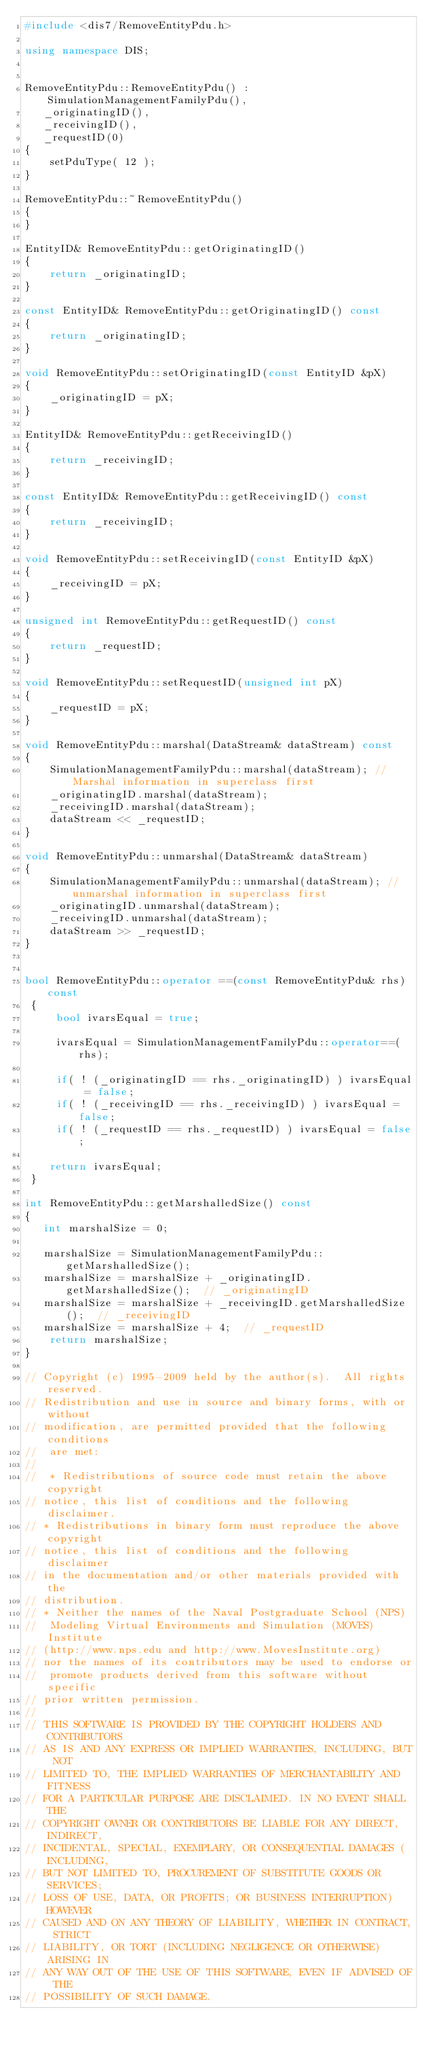Convert code to text. <code><loc_0><loc_0><loc_500><loc_500><_C++_>#include <dis7/RemoveEntityPdu.h>

using namespace DIS;


RemoveEntityPdu::RemoveEntityPdu() : SimulationManagementFamilyPdu(),
   _originatingID(), 
   _receivingID(), 
   _requestID(0)
{
    setPduType( 12 );
}

RemoveEntityPdu::~RemoveEntityPdu()
{
}

EntityID& RemoveEntityPdu::getOriginatingID() 
{
    return _originatingID;
}

const EntityID& RemoveEntityPdu::getOriginatingID() const
{
    return _originatingID;
}

void RemoveEntityPdu::setOriginatingID(const EntityID &pX)
{
    _originatingID = pX;
}

EntityID& RemoveEntityPdu::getReceivingID() 
{
    return _receivingID;
}

const EntityID& RemoveEntityPdu::getReceivingID() const
{
    return _receivingID;
}

void RemoveEntityPdu::setReceivingID(const EntityID &pX)
{
    _receivingID = pX;
}

unsigned int RemoveEntityPdu::getRequestID() const
{
    return _requestID;
}

void RemoveEntityPdu::setRequestID(unsigned int pX)
{
    _requestID = pX;
}

void RemoveEntityPdu::marshal(DataStream& dataStream) const
{
    SimulationManagementFamilyPdu::marshal(dataStream); // Marshal information in superclass first
    _originatingID.marshal(dataStream);
    _receivingID.marshal(dataStream);
    dataStream << _requestID;
}

void RemoveEntityPdu::unmarshal(DataStream& dataStream)
{
    SimulationManagementFamilyPdu::unmarshal(dataStream); // unmarshal information in superclass first
    _originatingID.unmarshal(dataStream);
    _receivingID.unmarshal(dataStream);
    dataStream >> _requestID;
}


bool RemoveEntityPdu::operator ==(const RemoveEntityPdu& rhs) const
 {
     bool ivarsEqual = true;

     ivarsEqual = SimulationManagementFamilyPdu::operator==(rhs);

     if( ! (_originatingID == rhs._originatingID) ) ivarsEqual = false;
     if( ! (_receivingID == rhs._receivingID) ) ivarsEqual = false;
     if( ! (_requestID == rhs._requestID) ) ivarsEqual = false;

    return ivarsEqual;
 }

int RemoveEntityPdu::getMarshalledSize() const
{
   int marshalSize = 0;

   marshalSize = SimulationManagementFamilyPdu::getMarshalledSize();
   marshalSize = marshalSize + _originatingID.getMarshalledSize();  // _originatingID
   marshalSize = marshalSize + _receivingID.getMarshalledSize();  // _receivingID
   marshalSize = marshalSize + 4;  // _requestID
    return marshalSize;
}

// Copyright (c) 1995-2009 held by the author(s).  All rights reserved.
// Redistribution and use in source and binary forms, with or without
// modification, are permitted provided that the following conditions
//  are met:
// 
//  * Redistributions of source code must retain the above copyright
// notice, this list of conditions and the following disclaimer.
// * Redistributions in binary form must reproduce the above copyright
// notice, this list of conditions and the following disclaimer
// in the documentation and/or other materials provided with the
// distribution.
// * Neither the names of the Naval Postgraduate School (NPS)
//  Modeling Virtual Environments and Simulation (MOVES) Institute
// (http://www.nps.edu and http://www.MovesInstitute.org)
// nor the names of its contributors may be used to endorse or
//  promote products derived from this software without specific
// prior written permission.
// 
// THIS SOFTWARE IS PROVIDED BY THE COPYRIGHT HOLDERS AND CONTRIBUTORS
// AS IS AND ANY EXPRESS OR IMPLIED WARRANTIES, INCLUDING, BUT NOT
// LIMITED TO, THE IMPLIED WARRANTIES OF MERCHANTABILITY AND FITNESS
// FOR A PARTICULAR PURPOSE ARE DISCLAIMED. IN NO EVENT SHALL THE
// COPYRIGHT OWNER OR CONTRIBUTORS BE LIABLE FOR ANY DIRECT, INDIRECT,
// INCIDENTAL, SPECIAL, EXEMPLARY, OR CONSEQUENTIAL DAMAGES (INCLUDING,
// BUT NOT LIMITED TO, PROCUREMENT OF SUBSTITUTE GOODS OR SERVICES;
// LOSS OF USE, DATA, OR PROFITS; OR BUSINESS INTERRUPTION) HOWEVER
// CAUSED AND ON ANY THEORY OF LIABILITY, WHETHER IN CONTRACT, STRICT
// LIABILITY, OR TORT (INCLUDING NEGLIGENCE OR OTHERWISE) ARISING IN
// ANY WAY OUT OF THE USE OF THIS SOFTWARE, EVEN IF ADVISED OF THE
// POSSIBILITY OF SUCH DAMAGE.
</code> 